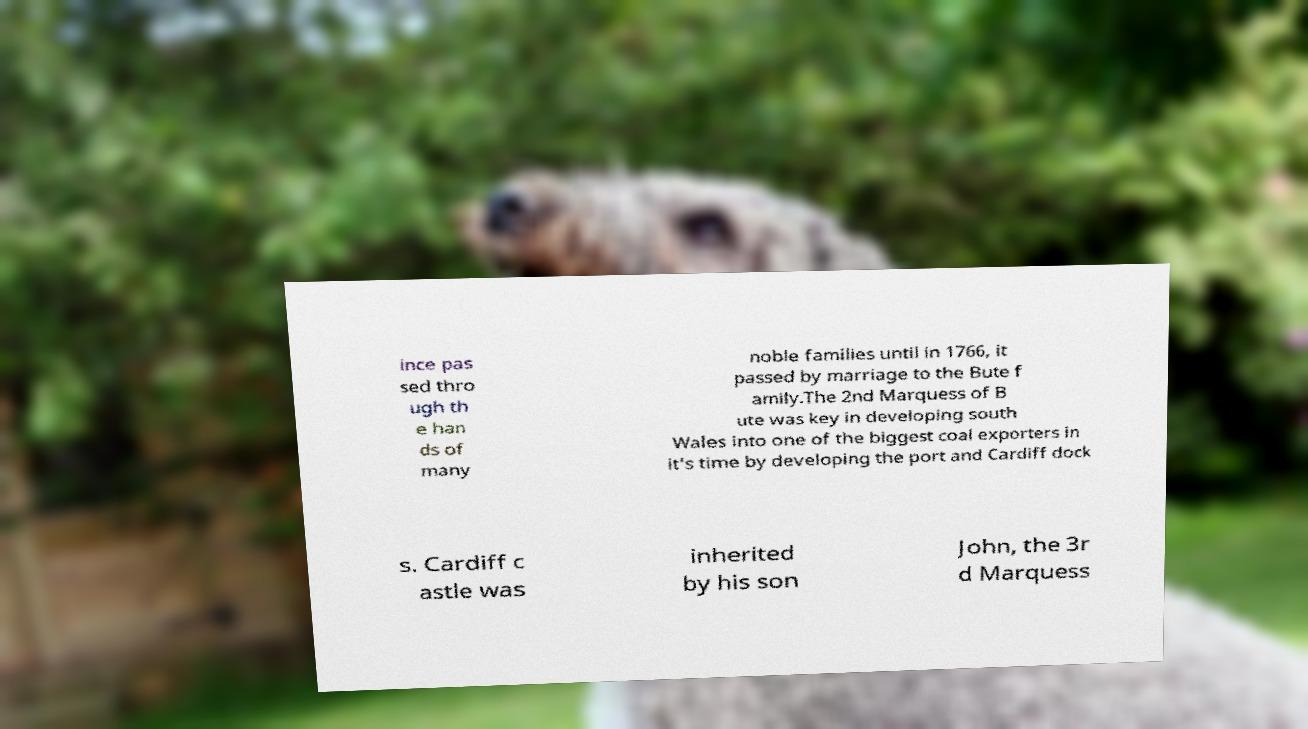There's text embedded in this image that I need extracted. Can you transcribe it verbatim? ince pas sed thro ugh th e han ds of many noble families until in 1766, it passed by marriage to the Bute f amily.The 2nd Marquess of B ute was key in developing south Wales into one of the biggest coal exporters in it's time by developing the port and Cardiff dock s. Cardiff c astle was inherited by his son John, the 3r d Marquess 